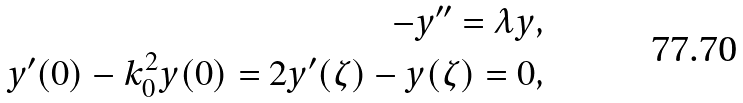<formula> <loc_0><loc_0><loc_500><loc_500>- y ^ { \prime \prime } = \lambda y , \\ y ^ { \prime } ( 0 ) - k _ { 0 } ^ { 2 } y ( 0 ) = 2 y ^ { \prime } ( \zeta ) - y ( \zeta ) = 0 ,</formula> 